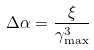<formula> <loc_0><loc_0><loc_500><loc_500>\Delta \alpha = \frac { \xi } { \gamma _ { \max } ^ { 3 } }</formula> 